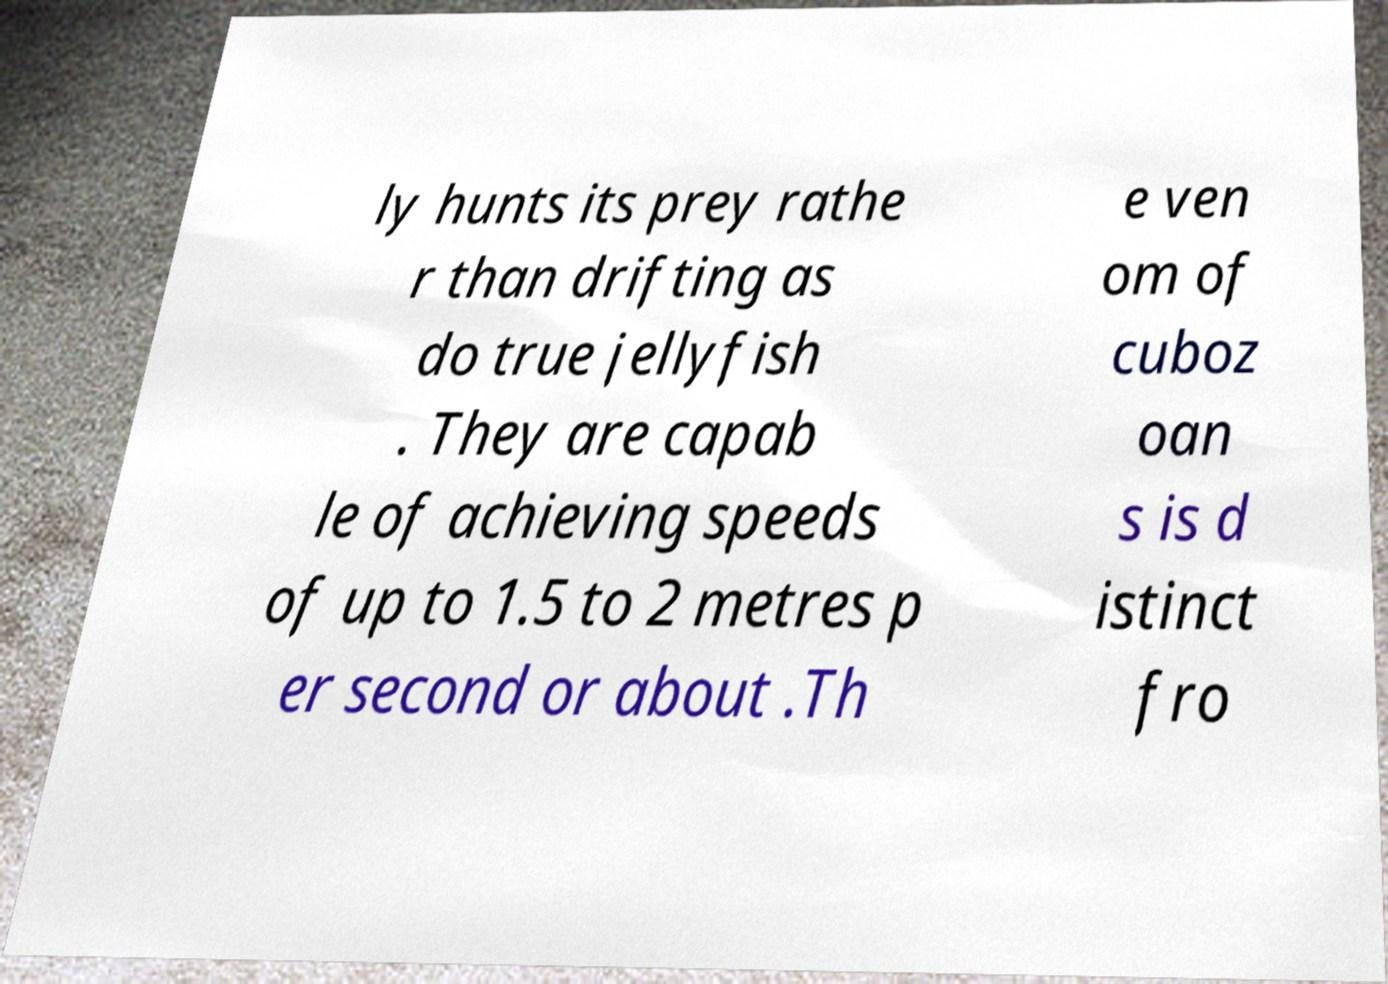Please identify and transcribe the text found in this image. ly hunts its prey rathe r than drifting as do true jellyfish . They are capab le of achieving speeds of up to 1.5 to 2 metres p er second or about .Th e ven om of cuboz oan s is d istinct fro 